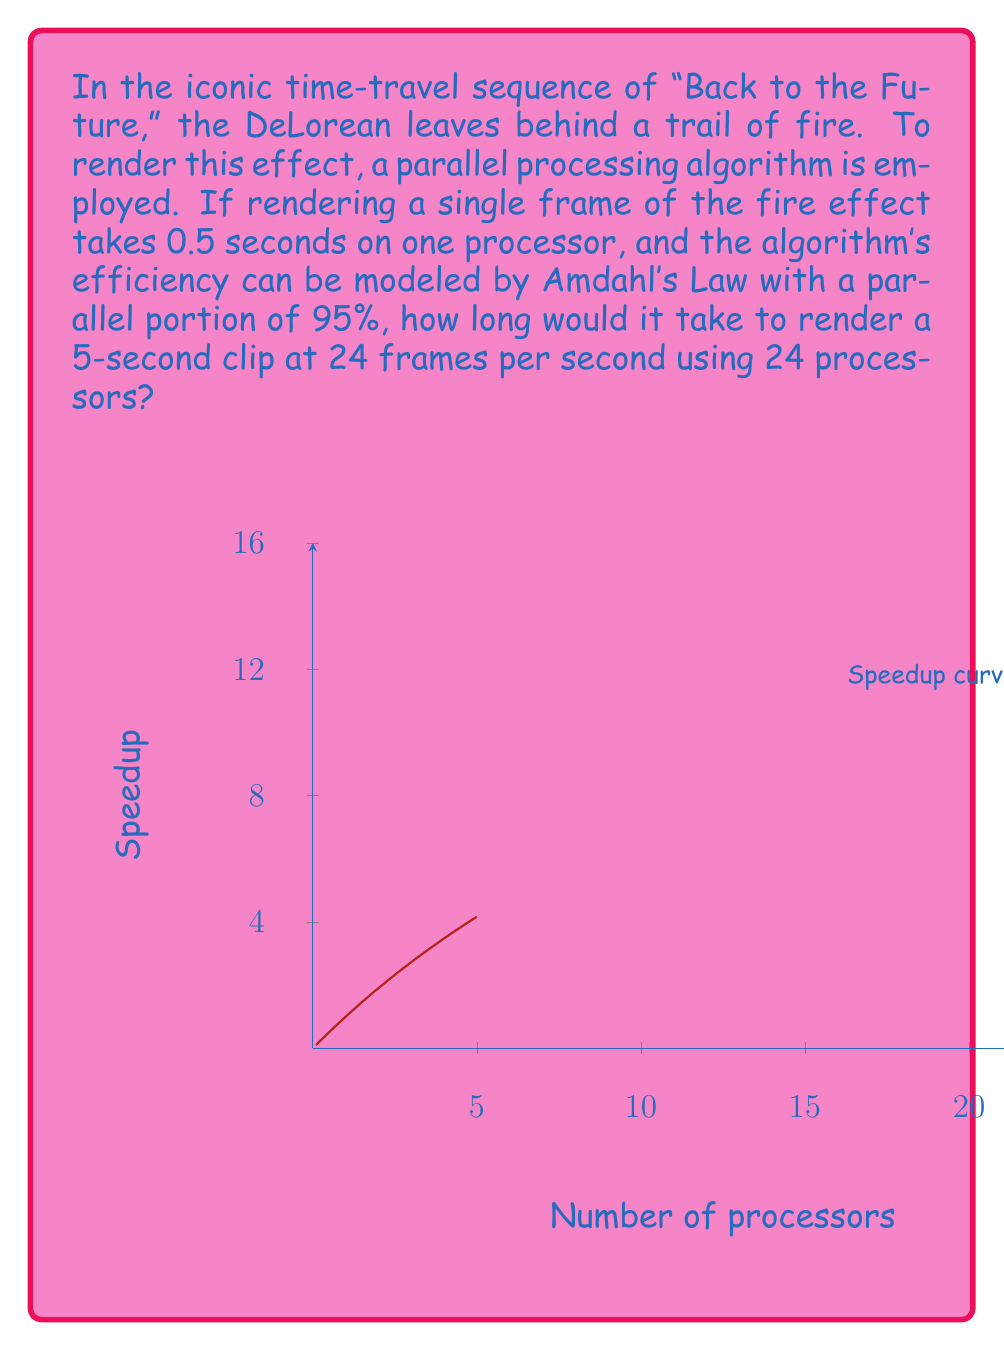Help me with this question. Let's approach this step-by-step:

1) First, calculate the total number of frames:
   5 seconds * 24 frames/second = 120 frames

2) Time to render one frame on a single processor: 0.5 seconds

3) Total time for all frames on a single processor:
   120 frames * 0.5 seconds/frame = 60 seconds

4) Now, we use Amdahl's Law to calculate the speedup with 24 processors:
   $$ S(n) = \frac{1}{(1-p) + \frac{p}{n}} $$
   where $S(n)$ is the speedup, $n$ is the number of processors, and $p$ is the parallel portion.

5) Plugging in our values:
   $$ S(24) = \frac{1}{(1-0.95) + \frac{0.95}{24}} = \frac{1}{0.05 + 0.0396} \approx 11.17 $$

6) The time with 24 processors is the single-processor time divided by the speedup:
   $$ T_{parallel} = \frac{T_{serial}}{S(n)} = \frac{60}{11.17} \approx 5.37 \text{ seconds} $$
Answer: 5.37 seconds 